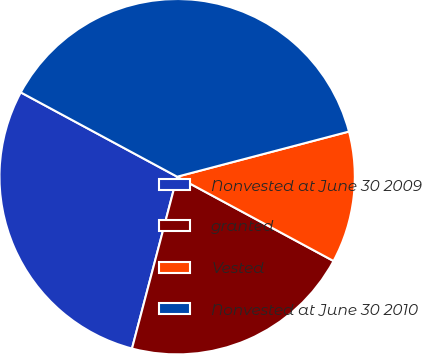Convert chart to OTSL. <chart><loc_0><loc_0><loc_500><loc_500><pie_chart><fcel>Nonvested at June 30 2009<fcel>granted<fcel>Vested<fcel>Nonvested at June 30 2010<nl><fcel>28.78%<fcel>21.22%<fcel>11.96%<fcel>38.04%<nl></chart> 